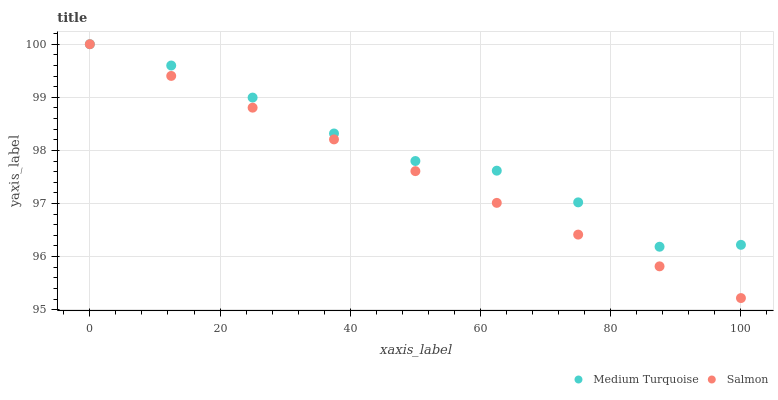Does Salmon have the minimum area under the curve?
Answer yes or no. Yes. Does Medium Turquoise have the maximum area under the curve?
Answer yes or no. Yes. Does Medium Turquoise have the minimum area under the curve?
Answer yes or no. No. Is Salmon the smoothest?
Answer yes or no. Yes. Is Medium Turquoise the roughest?
Answer yes or no. Yes. Is Medium Turquoise the smoothest?
Answer yes or no. No. Does Salmon have the lowest value?
Answer yes or no. Yes. Does Medium Turquoise have the lowest value?
Answer yes or no. No. Does Medium Turquoise have the highest value?
Answer yes or no. Yes. Does Salmon intersect Medium Turquoise?
Answer yes or no. Yes. Is Salmon less than Medium Turquoise?
Answer yes or no. No. Is Salmon greater than Medium Turquoise?
Answer yes or no. No. 